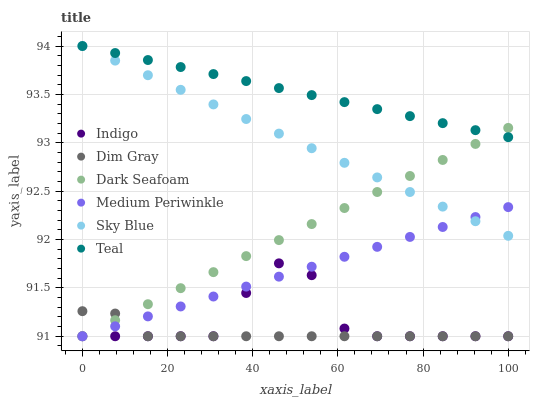Does Dim Gray have the minimum area under the curve?
Answer yes or no. Yes. Does Teal have the maximum area under the curve?
Answer yes or no. Yes. Does Indigo have the minimum area under the curve?
Answer yes or no. No. Does Indigo have the maximum area under the curve?
Answer yes or no. No. Is Medium Periwinkle the smoothest?
Answer yes or no. Yes. Is Indigo the roughest?
Answer yes or no. Yes. Is Indigo the smoothest?
Answer yes or no. No. Is Medium Periwinkle the roughest?
Answer yes or no. No. Does Dim Gray have the lowest value?
Answer yes or no. Yes. Does Teal have the lowest value?
Answer yes or no. No. Does Sky Blue have the highest value?
Answer yes or no. Yes. Does Indigo have the highest value?
Answer yes or no. No. Is Indigo less than Teal?
Answer yes or no. Yes. Is Teal greater than Dim Gray?
Answer yes or no. Yes. Does Sky Blue intersect Medium Periwinkle?
Answer yes or no. Yes. Is Sky Blue less than Medium Periwinkle?
Answer yes or no. No. Is Sky Blue greater than Medium Periwinkle?
Answer yes or no. No. Does Indigo intersect Teal?
Answer yes or no. No. 